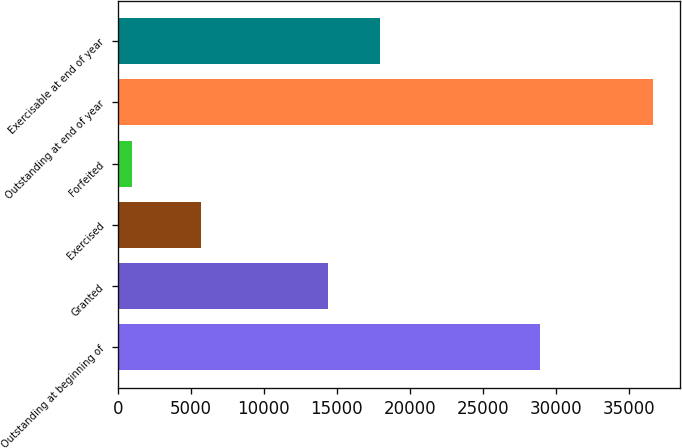<chart> <loc_0><loc_0><loc_500><loc_500><bar_chart><fcel>Outstanding at beginning of<fcel>Granted<fcel>Exercised<fcel>Forfeited<fcel>Outstanding at end of year<fcel>Exercisable at end of year<nl><fcel>28943<fcel>14423<fcel>5675<fcel>981<fcel>36710<fcel>17995.9<nl></chart> 